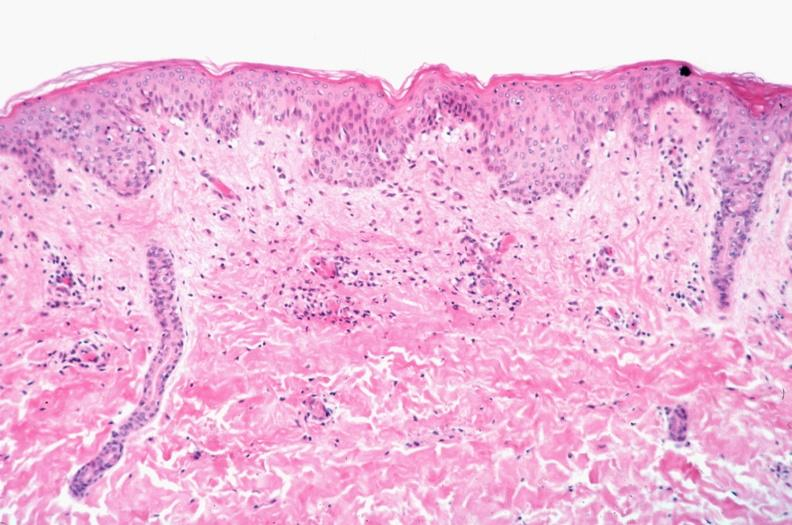what spotted fever, vasculitis?
Answer the question using a single word or phrase. Rocky mountain 